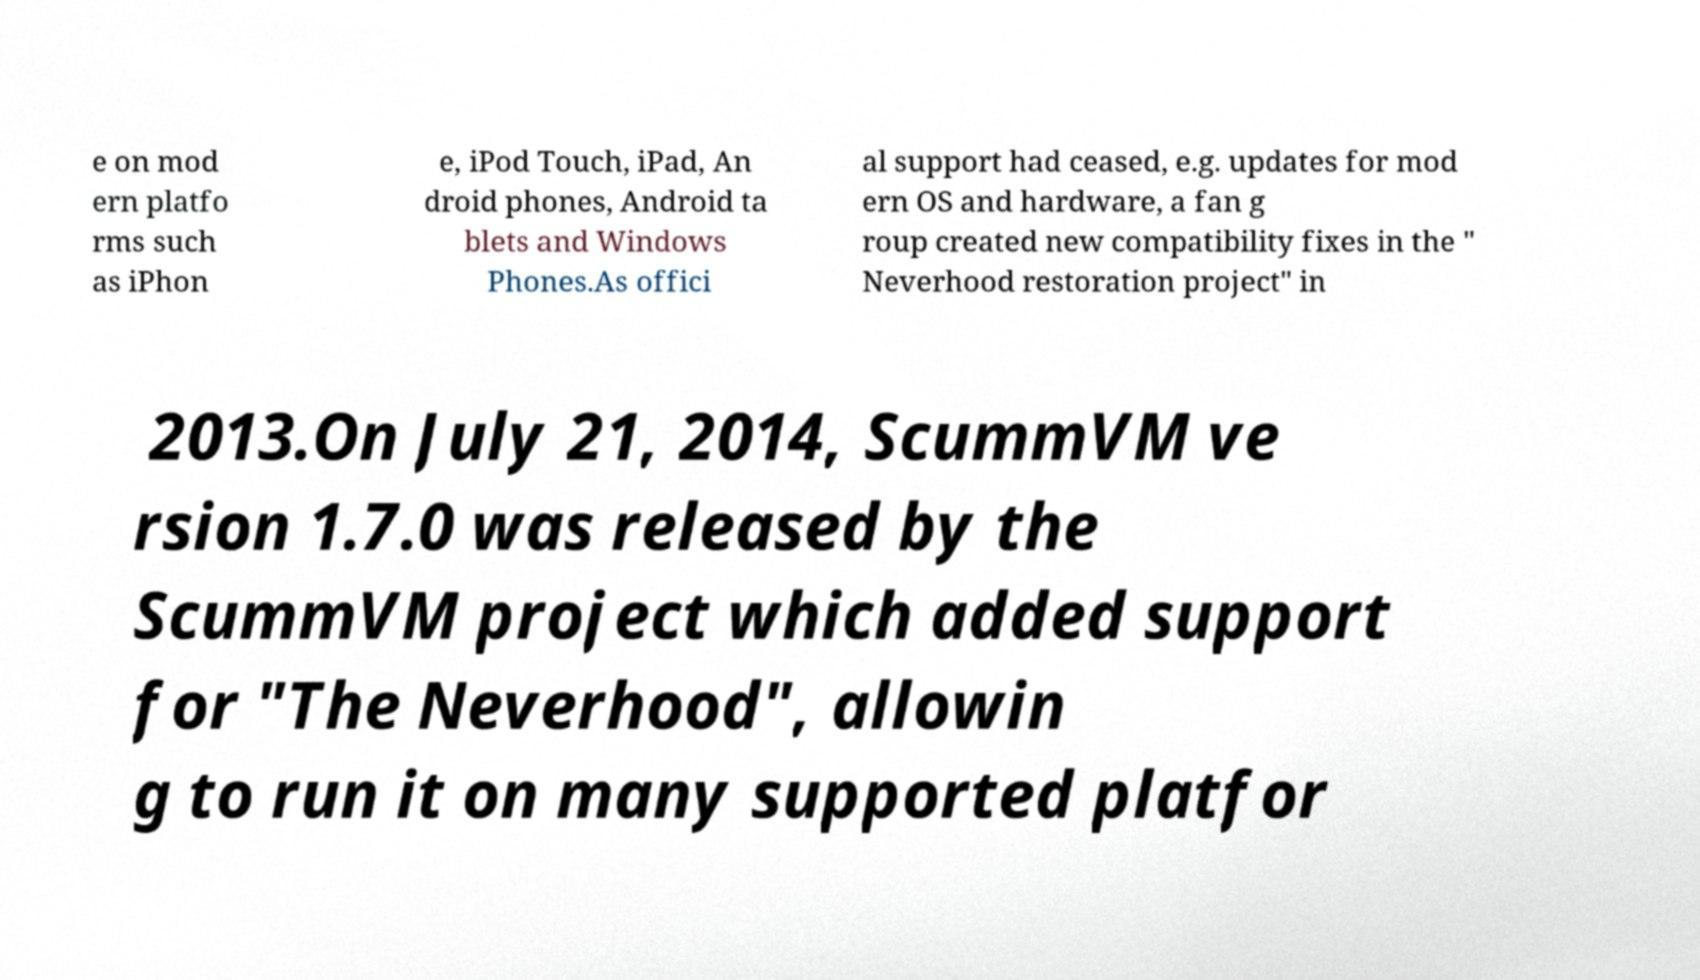Could you assist in decoding the text presented in this image and type it out clearly? e on mod ern platfo rms such as iPhon e, iPod Touch, iPad, An droid phones, Android ta blets and Windows Phones.As offici al support had ceased, e.g. updates for mod ern OS and hardware, a fan g roup created new compatibility fixes in the " Neverhood restoration project" in 2013.On July 21, 2014, ScummVM ve rsion 1.7.0 was released by the ScummVM project which added support for "The Neverhood", allowin g to run it on many supported platfor 